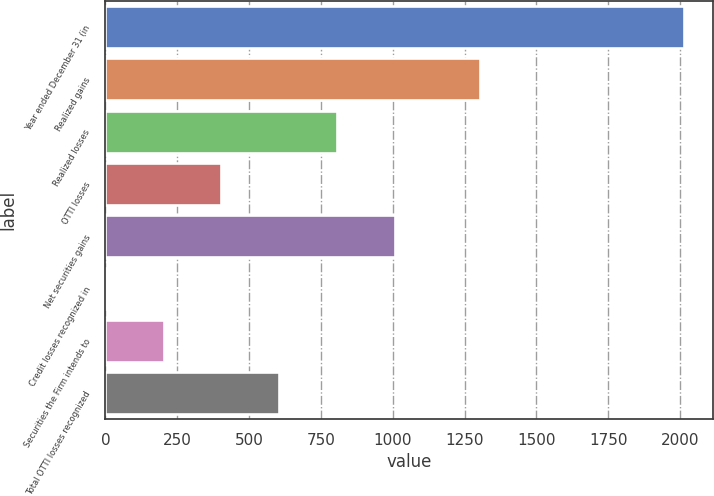Convert chart. <chart><loc_0><loc_0><loc_500><loc_500><bar_chart><fcel>Year ended December 31 (in<fcel>Realized gains<fcel>Realized losses<fcel>OTTI losses<fcel>Net securities gains<fcel>Credit losses recognized in<fcel>Securities the Firm intends to<fcel>Total OTTI losses recognized<nl><fcel>2013<fcel>1302<fcel>805.8<fcel>403.4<fcel>1007<fcel>1<fcel>202.2<fcel>604.6<nl></chart> 